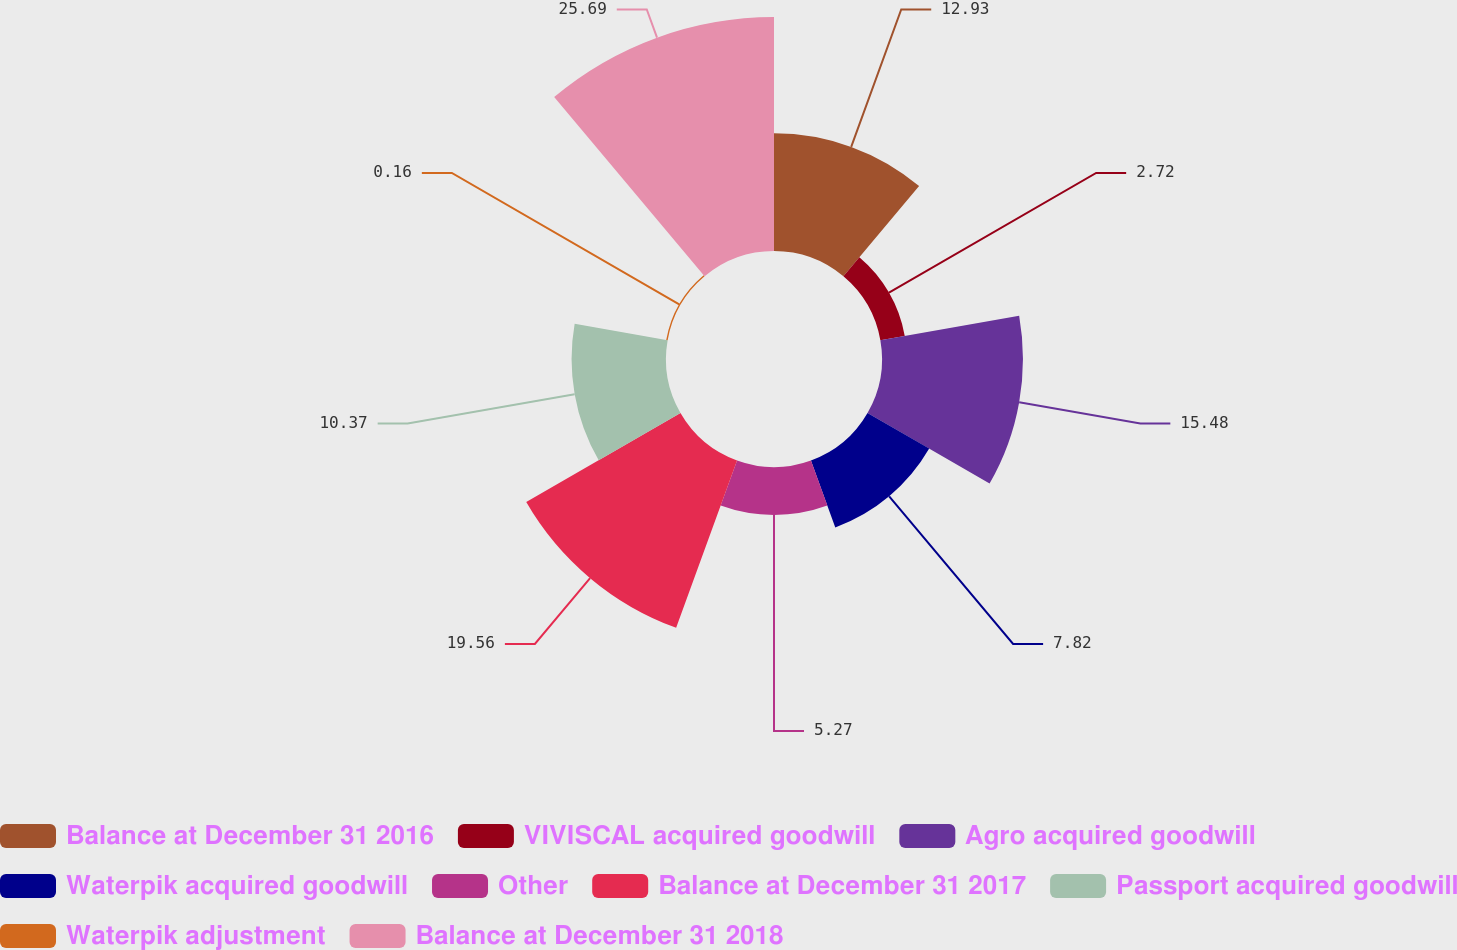Convert chart to OTSL. <chart><loc_0><loc_0><loc_500><loc_500><pie_chart><fcel>Balance at December 31 2016<fcel>VIVISCAL acquired goodwill<fcel>Agro acquired goodwill<fcel>Waterpik acquired goodwill<fcel>Other<fcel>Balance at December 31 2017<fcel>Passport acquired goodwill<fcel>Waterpik adjustment<fcel>Balance at December 31 2018<nl><fcel>12.93%<fcel>2.72%<fcel>15.48%<fcel>7.82%<fcel>5.27%<fcel>19.56%<fcel>10.37%<fcel>0.16%<fcel>25.7%<nl></chart> 